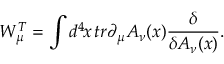<formula> <loc_0><loc_0><loc_500><loc_500>W _ { \mu } ^ { T } = \int d ^ { 4 } \, x \, t r \partial _ { \mu } A _ { \nu } ( x ) { \frac { \delta } { \delta A _ { \nu } ( x ) } } .</formula> 